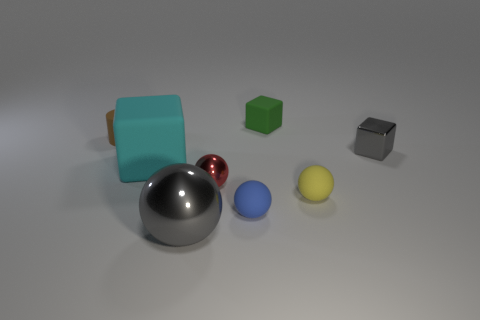How many objects are there, and can you describe them? There are a total of seven objects which include a large teal cube, a smaller green cube, a reflective brown cylinder, a shiny red sphere, a medium-sized matte blue sphere, a small bright yellow sphere, and a reflective grey cube. 